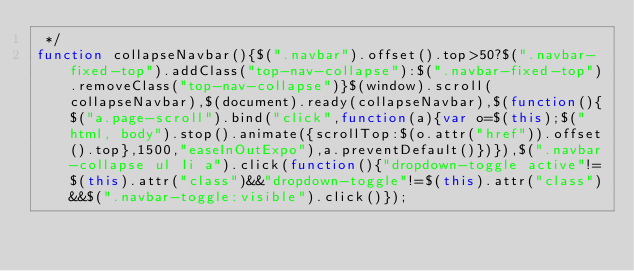Convert code to text. <code><loc_0><loc_0><loc_500><loc_500><_JavaScript_> */
function collapseNavbar(){$(".navbar").offset().top>50?$(".navbar-fixed-top").addClass("top-nav-collapse"):$(".navbar-fixed-top").removeClass("top-nav-collapse")}$(window).scroll(collapseNavbar),$(document).ready(collapseNavbar),$(function(){$("a.page-scroll").bind("click",function(a){var o=$(this);$("html, body").stop().animate({scrollTop:$(o.attr("href")).offset().top},1500,"easeInOutExpo"),a.preventDefault()})}),$(".navbar-collapse ul li a").click(function(){"dropdown-toggle active"!=$(this).attr("class")&&"dropdown-toggle"!=$(this).attr("class")&&$(".navbar-toggle:visible").click()});</code> 